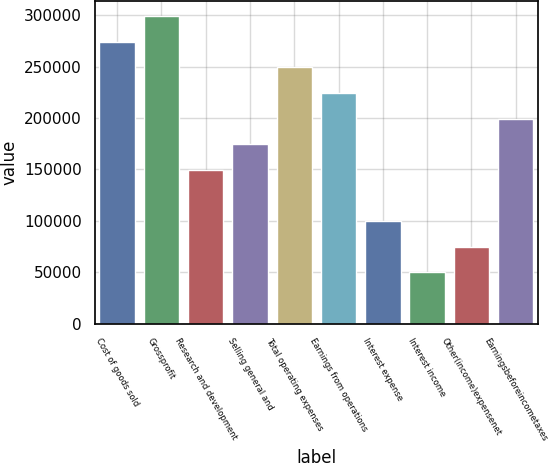<chart> <loc_0><loc_0><loc_500><loc_500><bar_chart><fcel>Cost of goods sold<fcel>Grossprofit<fcel>Research and development<fcel>Selling general and<fcel>Total operating expenses<fcel>Earnings from operations<fcel>Interest expense<fcel>Interest income<fcel>Other(income)expensenet<fcel>Earningsbeforeincometaxes<nl><fcel>274075<fcel>298991<fcel>149496<fcel>174412<fcel>249159<fcel>224243<fcel>99664.2<fcel>49832.6<fcel>74748.4<fcel>199327<nl></chart> 